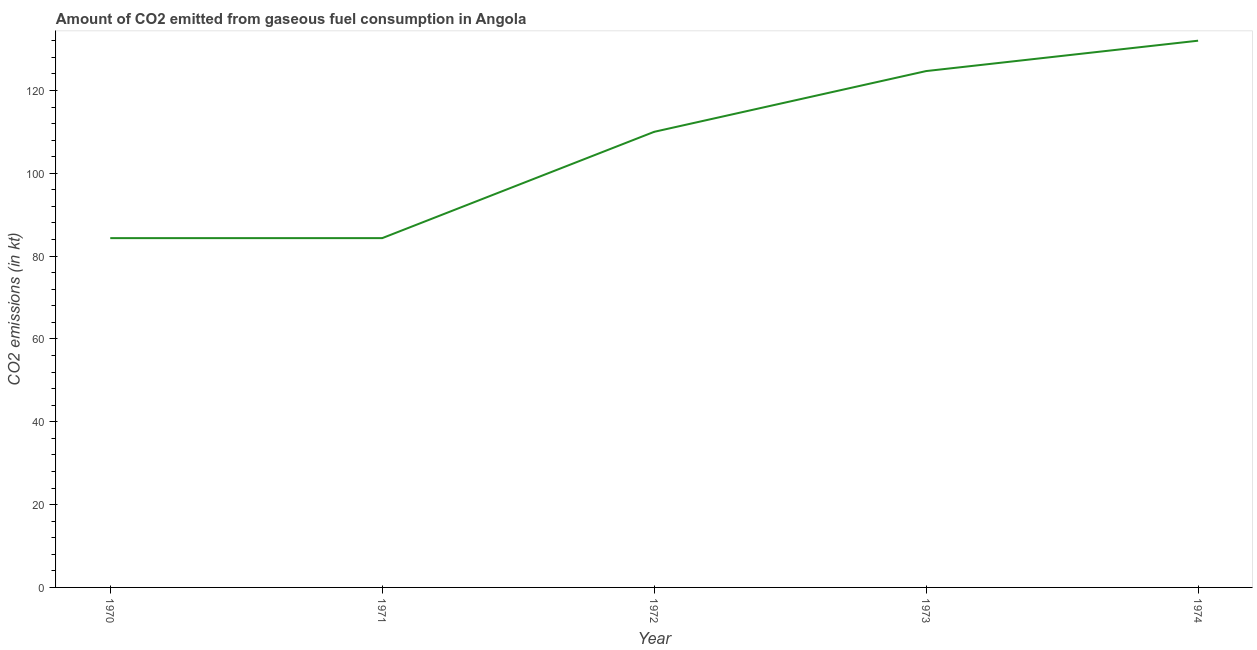What is the co2 emissions from gaseous fuel consumption in 1972?
Your response must be concise. 110.01. Across all years, what is the maximum co2 emissions from gaseous fuel consumption?
Ensure brevity in your answer.  132.01. Across all years, what is the minimum co2 emissions from gaseous fuel consumption?
Make the answer very short. 84.34. In which year was the co2 emissions from gaseous fuel consumption maximum?
Keep it short and to the point. 1974. In which year was the co2 emissions from gaseous fuel consumption minimum?
Your response must be concise. 1970. What is the sum of the co2 emissions from gaseous fuel consumption?
Provide a short and direct response. 535.38. What is the difference between the co2 emissions from gaseous fuel consumption in 1970 and 1973?
Provide a short and direct response. -40.34. What is the average co2 emissions from gaseous fuel consumption per year?
Your answer should be very brief. 107.08. What is the median co2 emissions from gaseous fuel consumption?
Offer a terse response. 110.01. Do a majority of the years between 1972 and 1970 (inclusive) have co2 emissions from gaseous fuel consumption greater than 72 kt?
Provide a succinct answer. No. What is the ratio of the co2 emissions from gaseous fuel consumption in 1970 to that in 1973?
Provide a succinct answer. 0.68. What is the difference between the highest and the second highest co2 emissions from gaseous fuel consumption?
Keep it short and to the point. 7.33. What is the difference between the highest and the lowest co2 emissions from gaseous fuel consumption?
Keep it short and to the point. 47.67. How many lines are there?
Your response must be concise. 1. How many years are there in the graph?
Provide a short and direct response. 5. Does the graph contain any zero values?
Your answer should be very brief. No. What is the title of the graph?
Make the answer very short. Amount of CO2 emitted from gaseous fuel consumption in Angola. What is the label or title of the Y-axis?
Provide a succinct answer. CO2 emissions (in kt). What is the CO2 emissions (in kt) of 1970?
Make the answer very short. 84.34. What is the CO2 emissions (in kt) in 1971?
Offer a terse response. 84.34. What is the CO2 emissions (in kt) in 1972?
Provide a succinct answer. 110.01. What is the CO2 emissions (in kt) in 1973?
Offer a very short reply. 124.68. What is the CO2 emissions (in kt) in 1974?
Offer a terse response. 132.01. What is the difference between the CO2 emissions (in kt) in 1970 and 1971?
Give a very brief answer. 0. What is the difference between the CO2 emissions (in kt) in 1970 and 1972?
Provide a succinct answer. -25.67. What is the difference between the CO2 emissions (in kt) in 1970 and 1973?
Your answer should be very brief. -40.34. What is the difference between the CO2 emissions (in kt) in 1970 and 1974?
Offer a terse response. -47.67. What is the difference between the CO2 emissions (in kt) in 1971 and 1972?
Offer a terse response. -25.67. What is the difference between the CO2 emissions (in kt) in 1971 and 1973?
Offer a terse response. -40.34. What is the difference between the CO2 emissions (in kt) in 1971 and 1974?
Provide a succinct answer. -47.67. What is the difference between the CO2 emissions (in kt) in 1972 and 1973?
Your response must be concise. -14.67. What is the difference between the CO2 emissions (in kt) in 1972 and 1974?
Offer a very short reply. -22. What is the difference between the CO2 emissions (in kt) in 1973 and 1974?
Your response must be concise. -7.33. What is the ratio of the CO2 emissions (in kt) in 1970 to that in 1972?
Ensure brevity in your answer.  0.77. What is the ratio of the CO2 emissions (in kt) in 1970 to that in 1973?
Ensure brevity in your answer.  0.68. What is the ratio of the CO2 emissions (in kt) in 1970 to that in 1974?
Make the answer very short. 0.64. What is the ratio of the CO2 emissions (in kt) in 1971 to that in 1972?
Your answer should be compact. 0.77. What is the ratio of the CO2 emissions (in kt) in 1971 to that in 1973?
Offer a very short reply. 0.68. What is the ratio of the CO2 emissions (in kt) in 1971 to that in 1974?
Ensure brevity in your answer.  0.64. What is the ratio of the CO2 emissions (in kt) in 1972 to that in 1973?
Offer a very short reply. 0.88. What is the ratio of the CO2 emissions (in kt) in 1972 to that in 1974?
Make the answer very short. 0.83. What is the ratio of the CO2 emissions (in kt) in 1973 to that in 1974?
Ensure brevity in your answer.  0.94. 